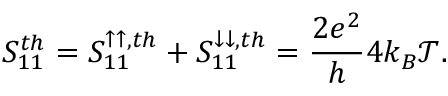<formula> <loc_0><loc_0><loc_500><loc_500>{ S _ { 1 1 } ^ { t h } = S _ { 1 1 } ^ { \uparrow \uparrow , t h } + S _ { 1 1 } ^ { \downarrow \downarrow , t h } = \frac { 2 e ^ { 2 } } { h } 4 k _ { B } \mathcal { T } } .</formula> 